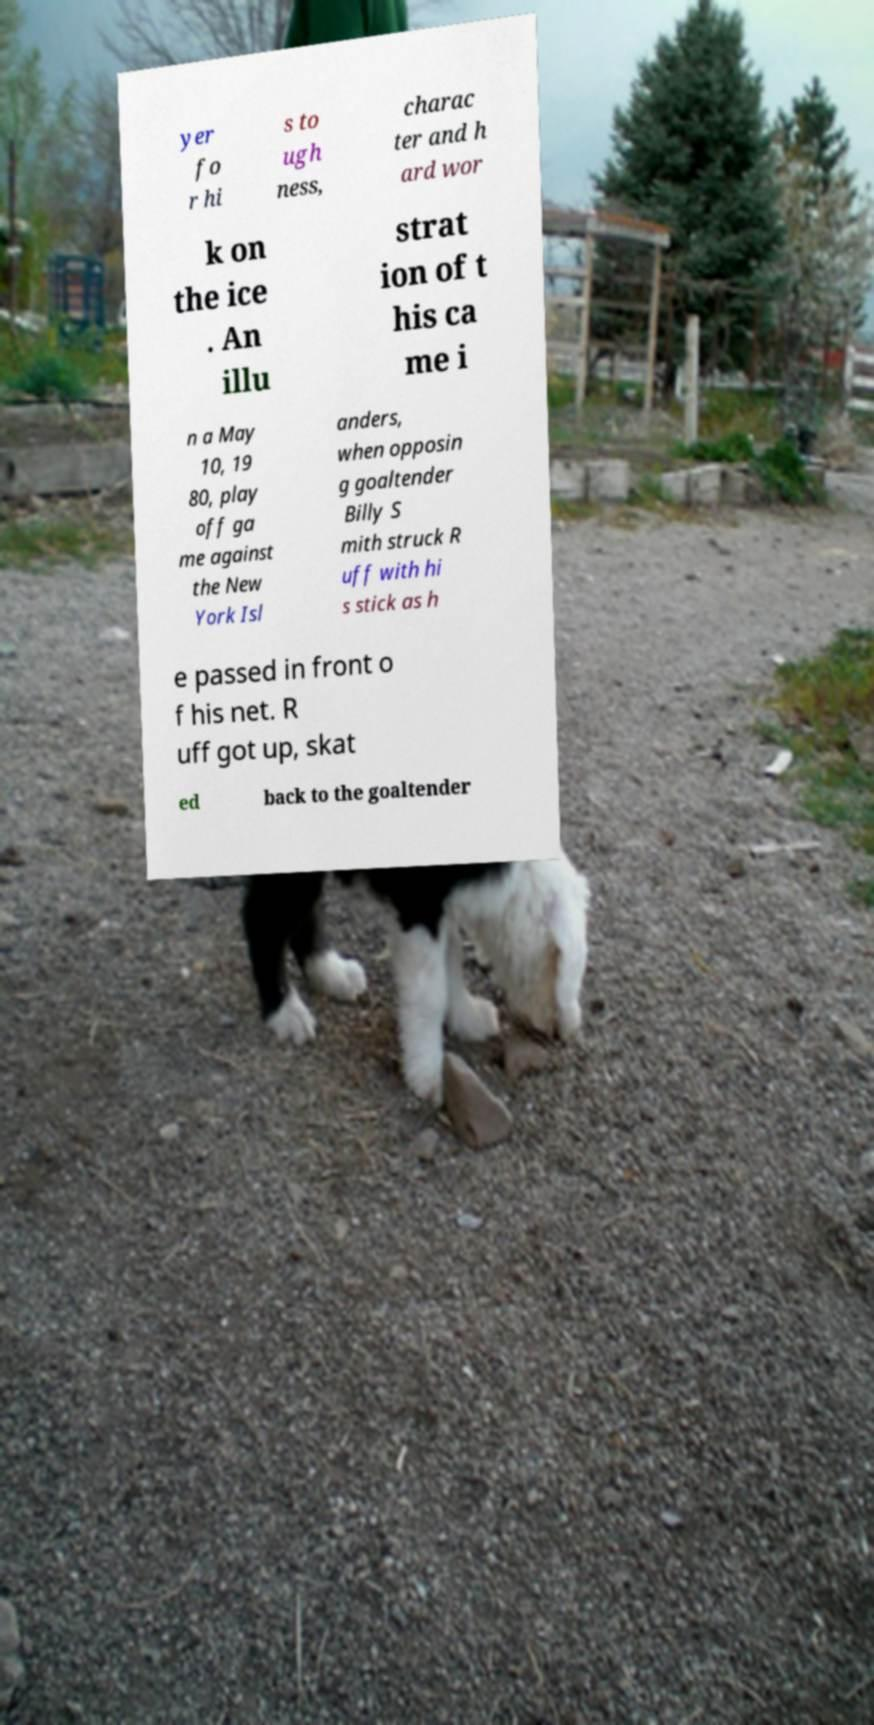Can you read and provide the text displayed in the image?This photo seems to have some interesting text. Can you extract and type it out for me? yer fo r hi s to ugh ness, charac ter and h ard wor k on the ice . An illu strat ion of t his ca me i n a May 10, 19 80, play off ga me against the New York Isl anders, when opposin g goaltender Billy S mith struck R uff with hi s stick as h e passed in front o f his net. R uff got up, skat ed back to the goaltender 